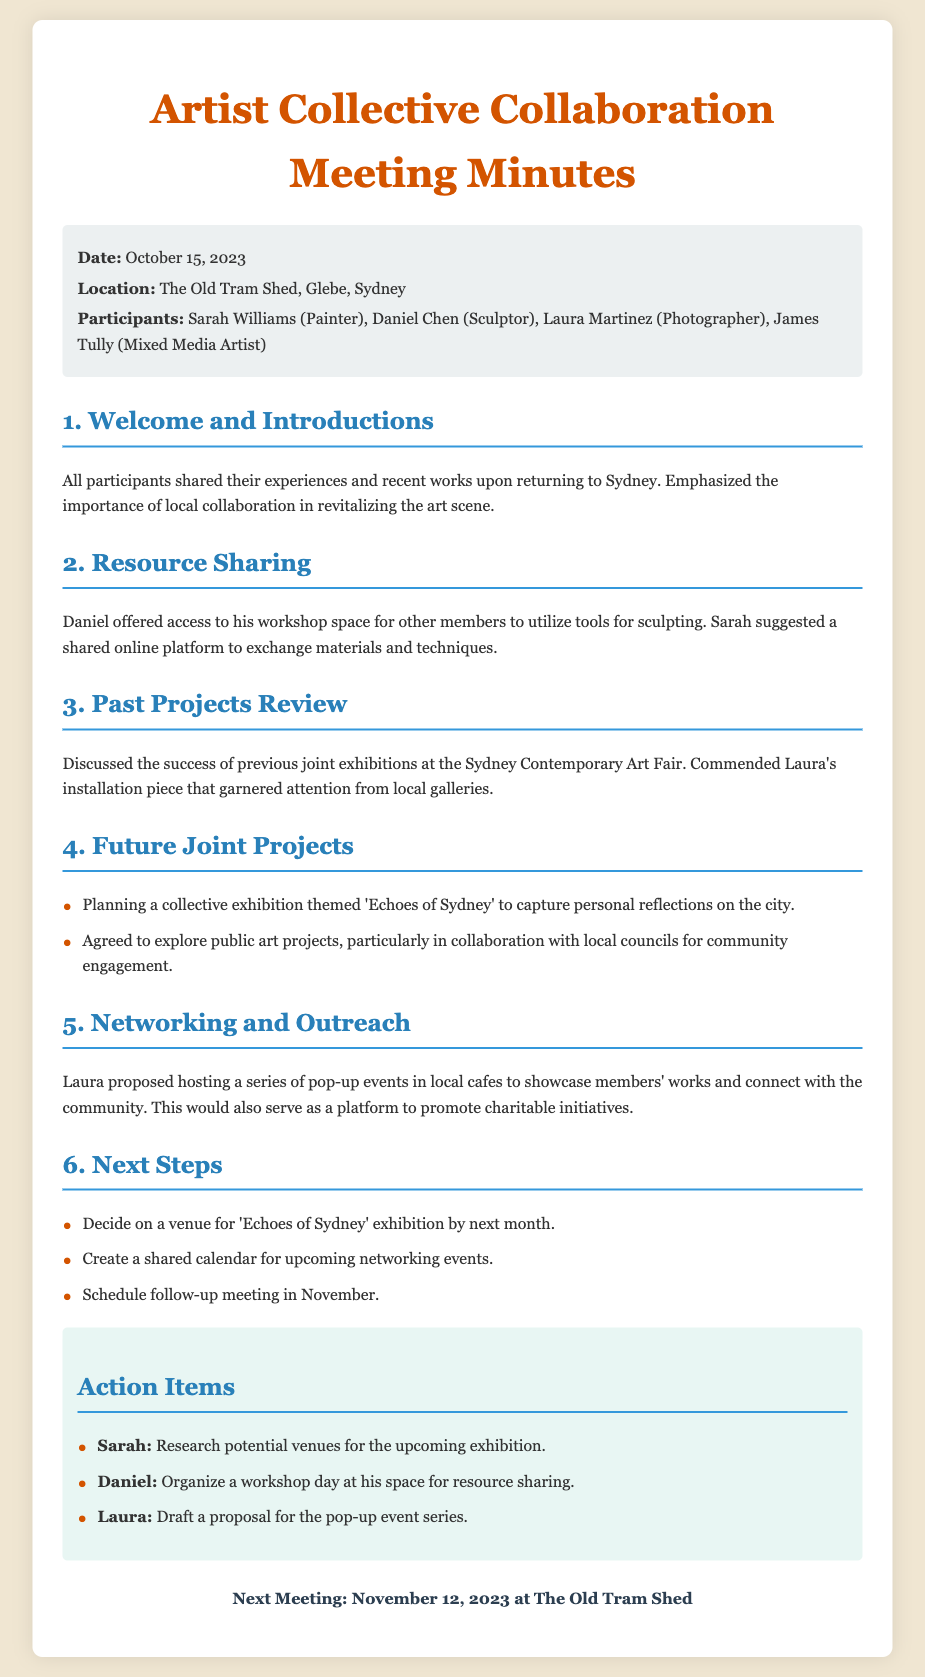what is the date of the meeting? The date of the meeting is mentioned in the meta-info section of the document.
Answer: October 15, 2023 where was the meeting held? The location of the meeting is provided in the meta-info section of the document.
Answer: The Old Tram Shed, Glebe, Sydney who proposed the pop-up event series? The person who proposed the pop-up event series is noted in the networking and outreach section.
Answer: Laura what is the theme of the upcoming exhibition? The theme for the collective exhibition is stated in the future joint projects section.
Answer: Echoes of Sydney how many action items are listed? The total number of action items can be counted in the action items section of the document.
Answer: Three when is the next meeting scheduled? The date of the next meeting is mentioned at the end of the document.
Answer: November 12, 2023 who will organize the workshop day? The person responsible for organizing the workshop day is noted in the action items section.
Answer: Daniel what should Sarah research for the next steps? The specific task for Sarah is described in the action items section.
Answer: Potential venues for the upcoming exhibition what type of events did Laura propose for community engagement? The type of events proposed by Laura is specified in the networking and outreach section of the document.
Answer: Pop-up events 